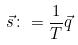<formula> <loc_0><loc_0><loc_500><loc_500>\vec { s } \colon = \frac { 1 } { T } \vec { q }</formula> 